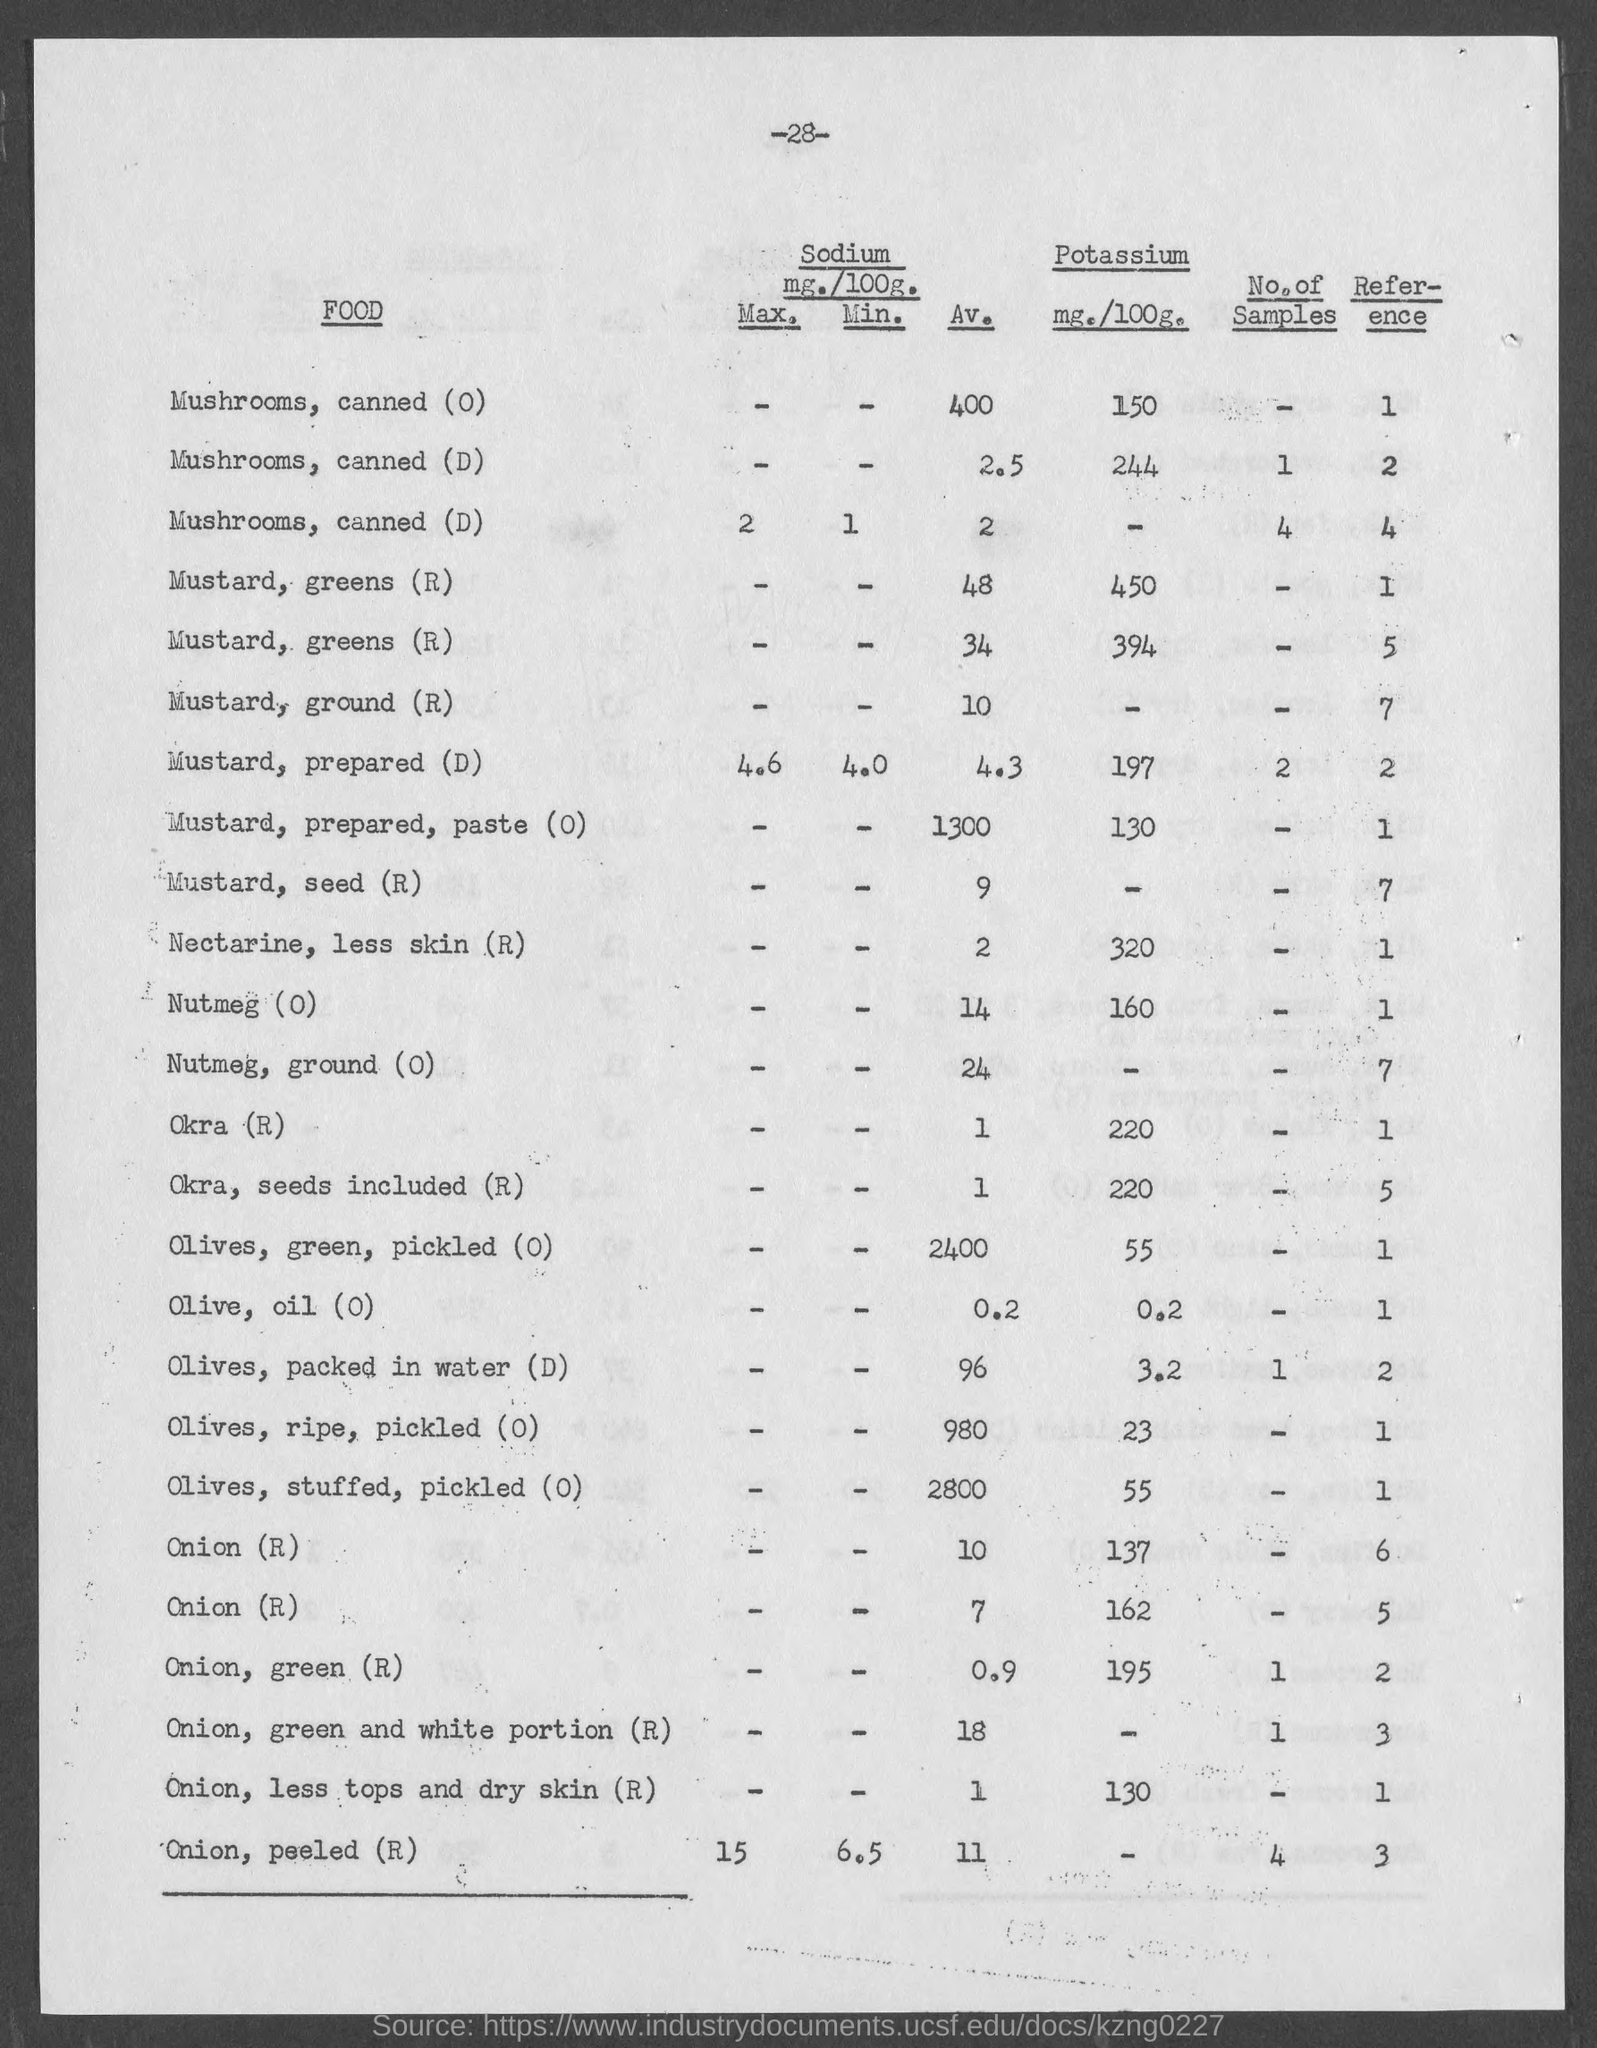What is the potassium mg./100g. for mustard, prepared (d)?
Offer a very short reply. 197. What is the potassium mg./100g. for mustard, prepared, paste (o)?
Provide a succinct answer. 130. What is the potassium mg./100g. for nectarine, less skin (r)?
Your answer should be very brief. 320. What is the potassium mg./100g. for nutmeg (o)?
Provide a short and direct response. 160. What is the potassium mg./100g. for okra (r)?
Provide a succinct answer. 220. What is the potassium mg./100g. for  okra, seeds included (r)?
Keep it short and to the point. 220. What is the potassium mg./100g. for  olives,green, pickled (o)?
Make the answer very short. 55. What is the potassium mg./100g. for olive, oil(o)?
Make the answer very short. 0.2. What is the potassium mg./100g. for onion, green (r)?
Make the answer very short. 195. 